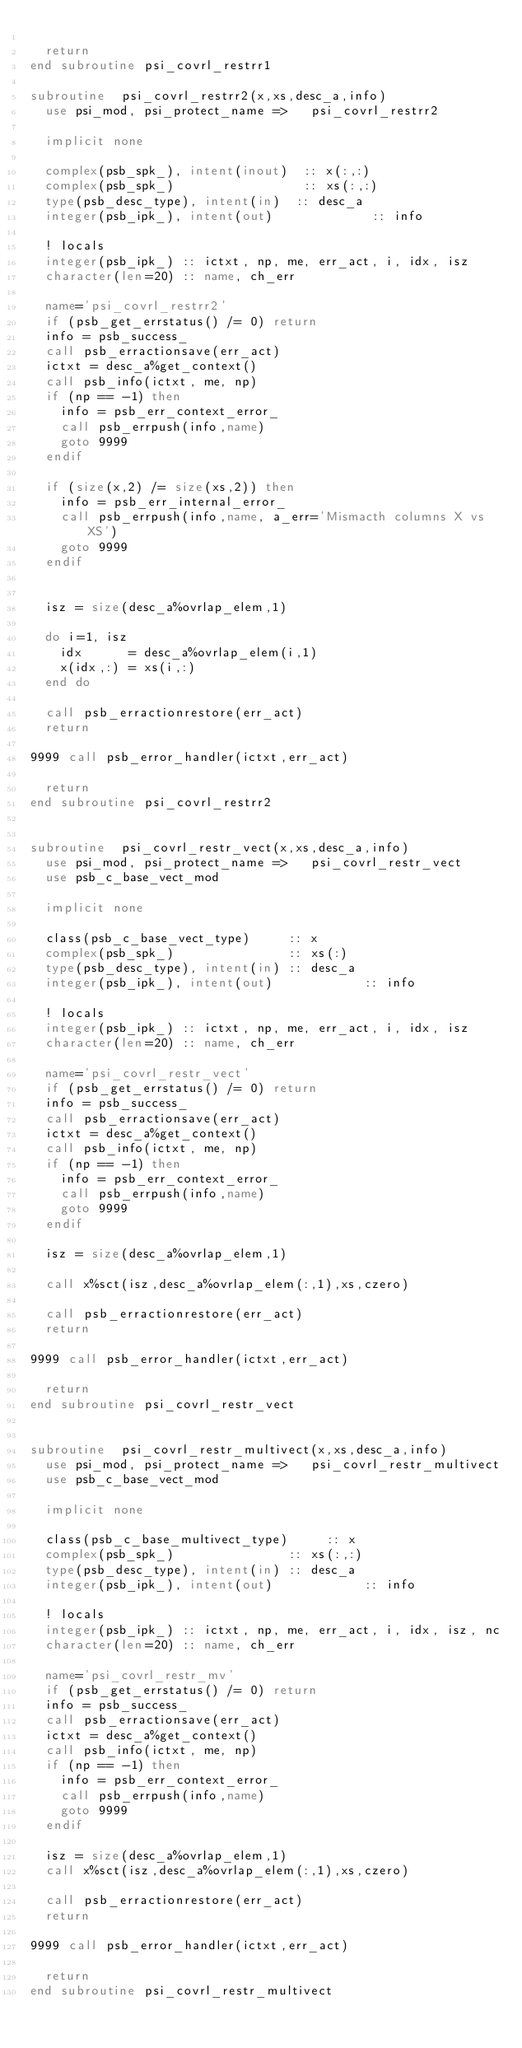Convert code to text. <code><loc_0><loc_0><loc_500><loc_500><_FORTRAN_>
  return
end subroutine psi_covrl_restrr1

subroutine  psi_covrl_restrr2(x,xs,desc_a,info)
  use psi_mod, psi_protect_name =>   psi_covrl_restrr2

  implicit none

  complex(psb_spk_), intent(inout)  :: x(:,:)
  complex(psb_spk_)                 :: xs(:,:)
  type(psb_desc_type), intent(in)  :: desc_a
  integer(psb_ipk_), intent(out)             :: info

  ! locals
  integer(psb_ipk_) :: ictxt, np, me, err_act, i, idx, isz
  character(len=20) :: name, ch_err

  name='psi_covrl_restrr2'
  if (psb_get_errstatus() /= 0) return 
  info = psb_success_
  call psb_erractionsave(err_act)
  ictxt = desc_a%get_context()
  call psb_info(ictxt, me, np)
  if (np == -1) then
    info = psb_err_context_error_
    call psb_errpush(info,name)
    goto 9999
  endif

  if (size(x,2) /= size(xs,2)) then 
    info = psb_err_internal_error_
    call psb_errpush(info,name, a_err='Mismacth columns X vs XS')
    goto 9999
  endif


  isz = size(desc_a%ovrlap_elem,1)

  do i=1, isz
    idx      = desc_a%ovrlap_elem(i,1)
    x(idx,:) = xs(i,:) 
  end do

  call psb_erractionrestore(err_act)
  return  

9999 call psb_error_handler(ictxt,err_act)

  return
end subroutine psi_covrl_restrr2


subroutine  psi_covrl_restr_vect(x,xs,desc_a,info)
  use psi_mod, psi_protect_name =>   psi_covrl_restr_vect
  use psb_c_base_vect_mod

  implicit none

  class(psb_c_base_vect_type)     :: x
  complex(psb_spk_)               :: xs(:)
  type(psb_desc_type), intent(in) :: desc_a
  integer(psb_ipk_), intent(out)            :: info

  ! locals
  integer(psb_ipk_) :: ictxt, np, me, err_act, i, idx, isz
  character(len=20) :: name, ch_err

  name='psi_covrl_restr_vect'
  if (psb_get_errstatus() /= 0) return 
  info = psb_success_
  call psb_erractionsave(err_act)
  ictxt = desc_a%get_context()
  call psb_info(ictxt, me, np)
  if (np == -1) then
    info = psb_err_context_error_
    call psb_errpush(info,name)
    goto 9999
  endif

  isz = size(desc_a%ovrlap_elem,1)

  call x%sct(isz,desc_a%ovrlap_elem(:,1),xs,czero)

  call psb_erractionrestore(err_act)
  return  

9999 call psb_error_handler(ictxt,err_act)

  return
end subroutine psi_covrl_restr_vect


subroutine  psi_covrl_restr_multivect(x,xs,desc_a,info)
  use psi_mod, psi_protect_name =>   psi_covrl_restr_multivect
  use psb_c_base_vect_mod

  implicit none

  class(psb_c_base_multivect_type)     :: x
  complex(psb_spk_)               :: xs(:,:)
  type(psb_desc_type), intent(in) :: desc_a
  integer(psb_ipk_), intent(out)            :: info

  ! locals
  integer(psb_ipk_) :: ictxt, np, me, err_act, i, idx, isz, nc
  character(len=20) :: name, ch_err

  name='psi_covrl_restr_mv'
  if (psb_get_errstatus() /= 0) return 
  info = psb_success_
  call psb_erractionsave(err_act)
  ictxt = desc_a%get_context()
  call psb_info(ictxt, me, np)
  if (np == -1) then
    info = psb_err_context_error_
    call psb_errpush(info,name)
    goto 9999
  endif

  isz = size(desc_a%ovrlap_elem,1)
  call x%sct(isz,desc_a%ovrlap_elem(:,1),xs,czero)

  call psb_erractionrestore(err_act)
  return  

9999 call psb_error_handler(ictxt,err_act)

  return
end subroutine psi_covrl_restr_multivect


</code> 